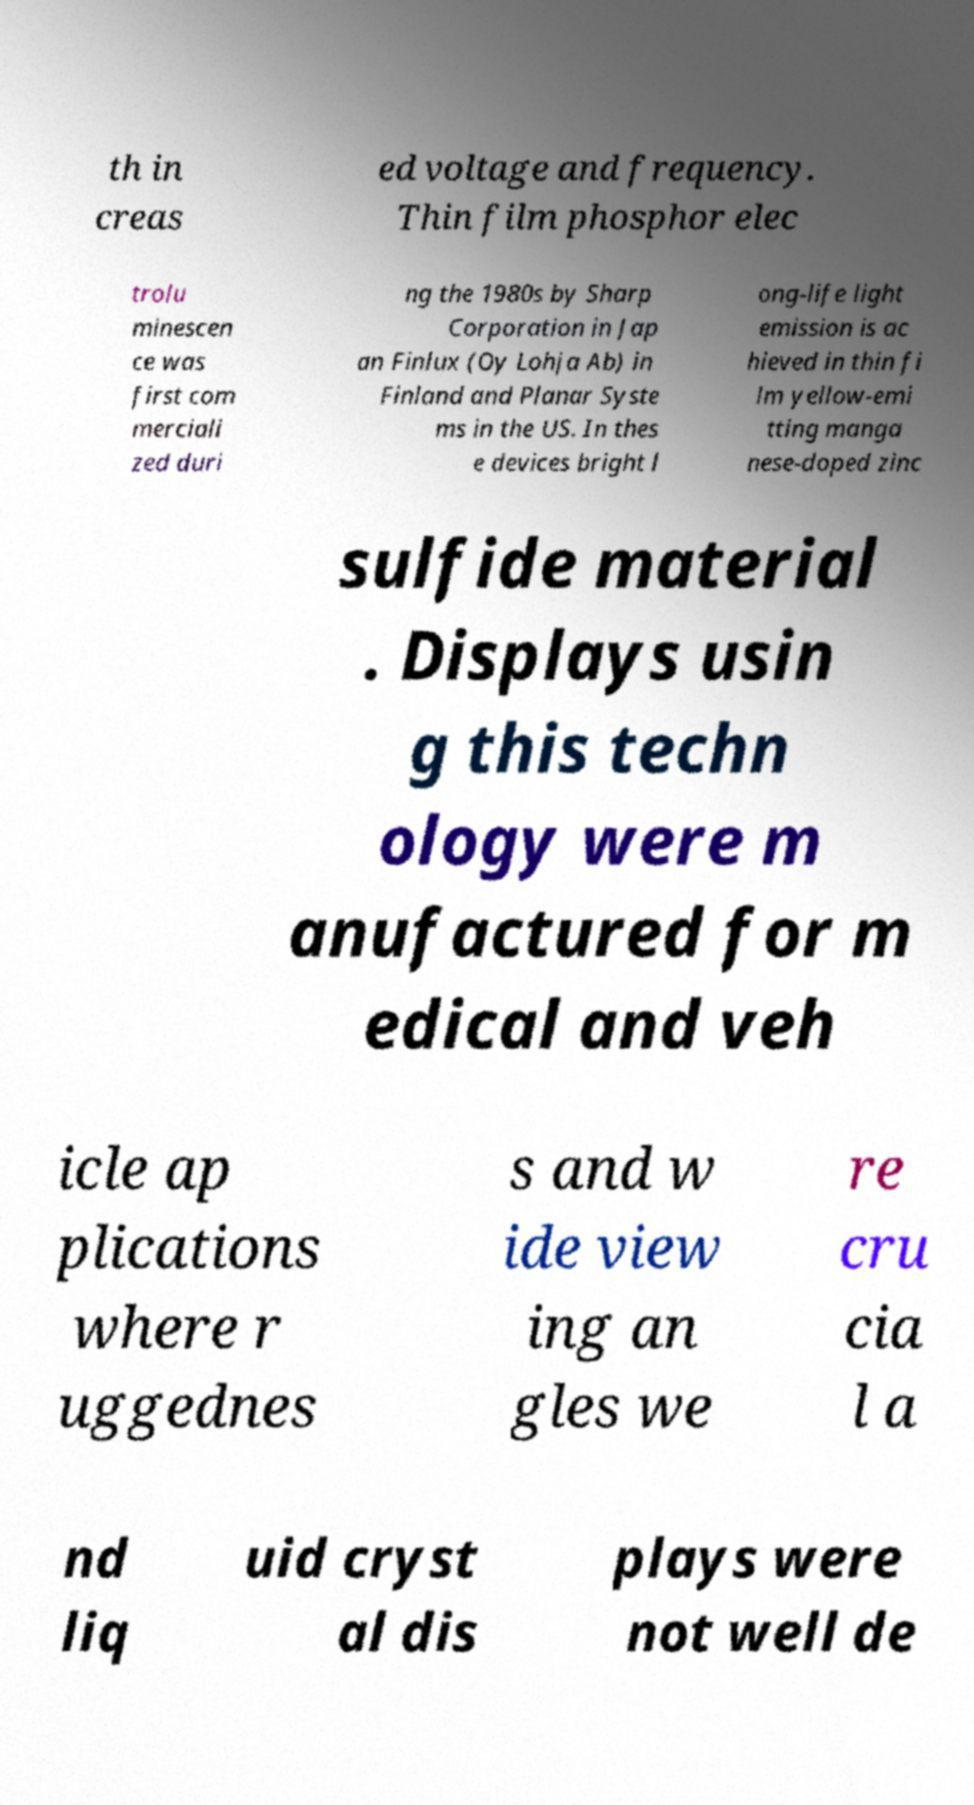Please read and relay the text visible in this image. What does it say? th in creas ed voltage and frequency. Thin film phosphor elec trolu minescen ce was first com merciali zed duri ng the 1980s by Sharp Corporation in Jap an Finlux (Oy Lohja Ab) in Finland and Planar Syste ms in the US. In thes e devices bright l ong-life light emission is ac hieved in thin fi lm yellow-emi tting manga nese-doped zinc sulfide material . Displays usin g this techn ology were m anufactured for m edical and veh icle ap plications where r uggednes s and w ide view ing an gles we re cru cia l a nd liq uid cryst al dis plays were not well de 